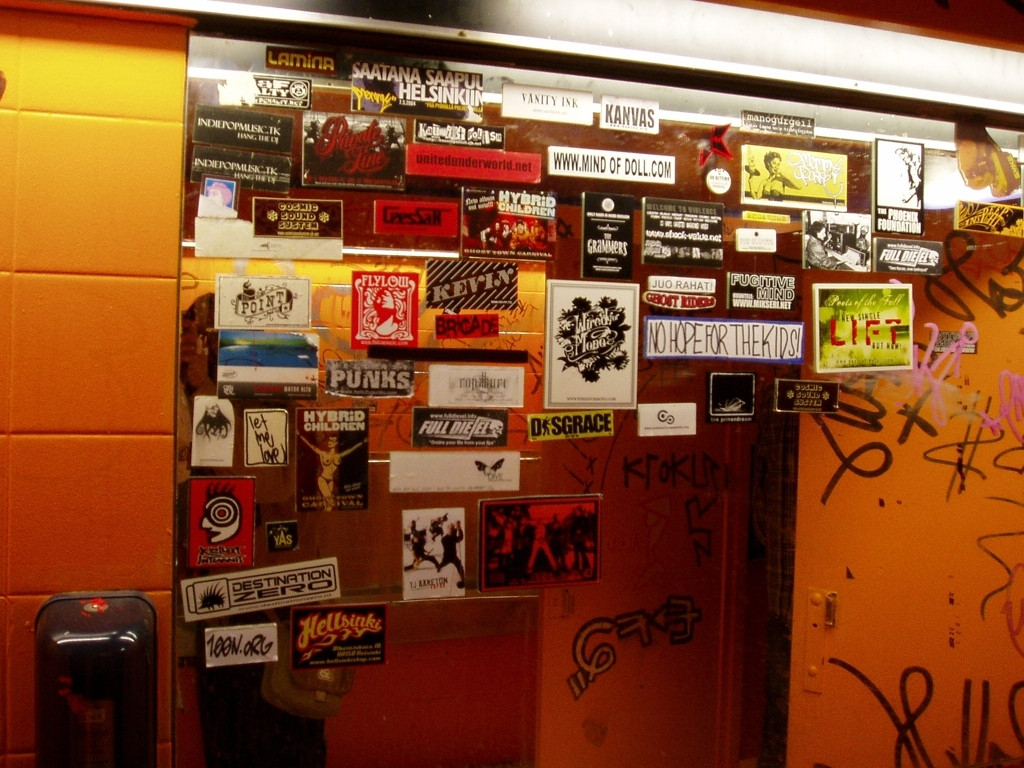How would you describe the atmosphere or mood conveyed by this image? The atmosphere conveyed by the image is one of urban grit and subcultural vibrancy. The numerous stickers and graffiti tags suggest a location that's frequented by creative individuals keen on expressing their identities and messages. Despite the somewhat cool and shadowy ambiance, there's a sense of energy and defiance that's common in spaces showcasing street art. 